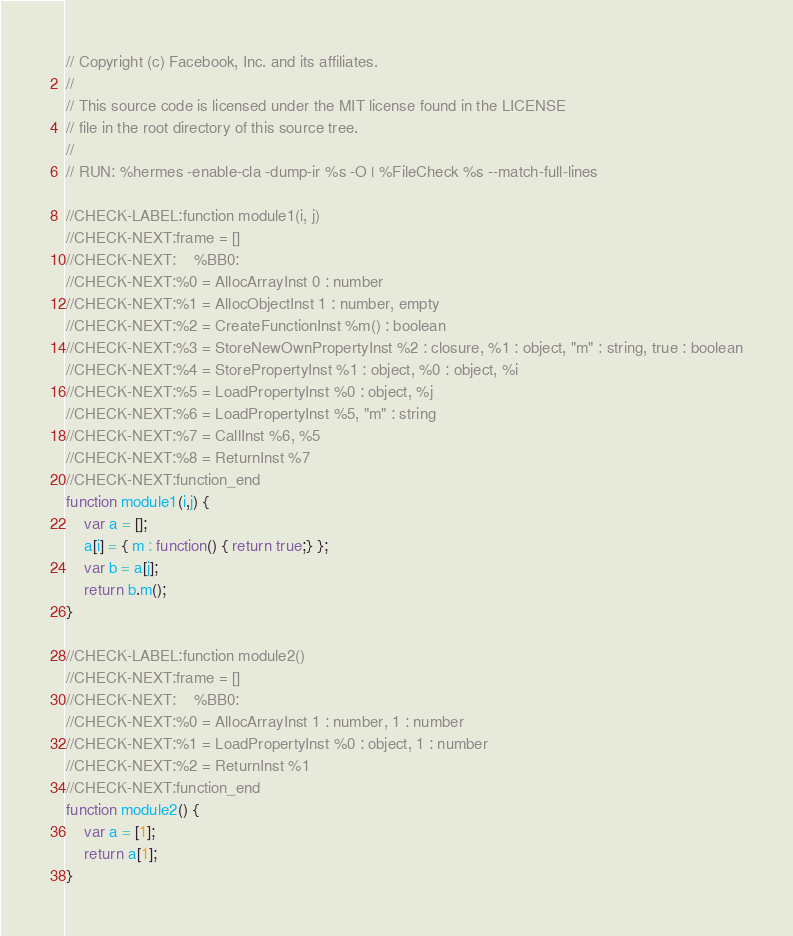Convert code to text. <code><loc_0><loc_0><loc_500><loc_500><_JavaScript_>// Copyright (c) Facebook, Inc. and its affiliates.
//
// This source code is licensed under the MIT license found in the LICENSE
// file in the root directory of this source tree.
//
// RUN: %hermes -enable-cla -dump-ir %s -O | %FileCheck %s --match-full-lines

//CHECK-LABEL:function module1(i, j)
//CHECK-NEXT:frame = []
//CHECK-NEXT:    %BB0:
//CHECK-NEXT:%0 = AllocArrayInst 0 : number
//CHECK-NEXT:%1 = AllocObjectInst 1 : number, empty
//CHECK-NEXT:%2 = CreateFunctionInst %m() : boolean
//CHECK-NEXT:%3 = StoreNewOwnPropertyInst %2 : closure, %1 : object, "m" : string, true : boolean
//CHECK-NEXT:%4 = StorePropertyInst %1 : object, %0 : object, %i
//CHECK-NEXT:%5 = LoadPropertyInst %0 : object, %j
//CHECK-NEXT:%6 = LoadPropertyInst %5, "m" : string
//CHECK-NEXT:%7 = CallInst %6, %5
//CHECK-NEXT:%8 = ReturnInst %7
//CHECK-NEXT:function_end
function module1(i,j) {
    var a = [];
    a[i] = { m : function() { return true;} };
    var b = a[j];
    return b.m();
}

//CHECK-LABEL:function module2()
//CHECK-NEXT:frame = []
//CHECK-NEXT:    %BB0:
//CHECK-NEXT:%0 = AllocArrayInst 1 : number, 1 : number
//CHECK-NEXT:%1 = LoadPropertyInst %0 : object, 1 : number
//CHECK-NEXT:%2 = ReturnInst %1
//CHECK-NEXT:function_end
function module2() {
    var a = [1];
    return a[1];
}
</code> 